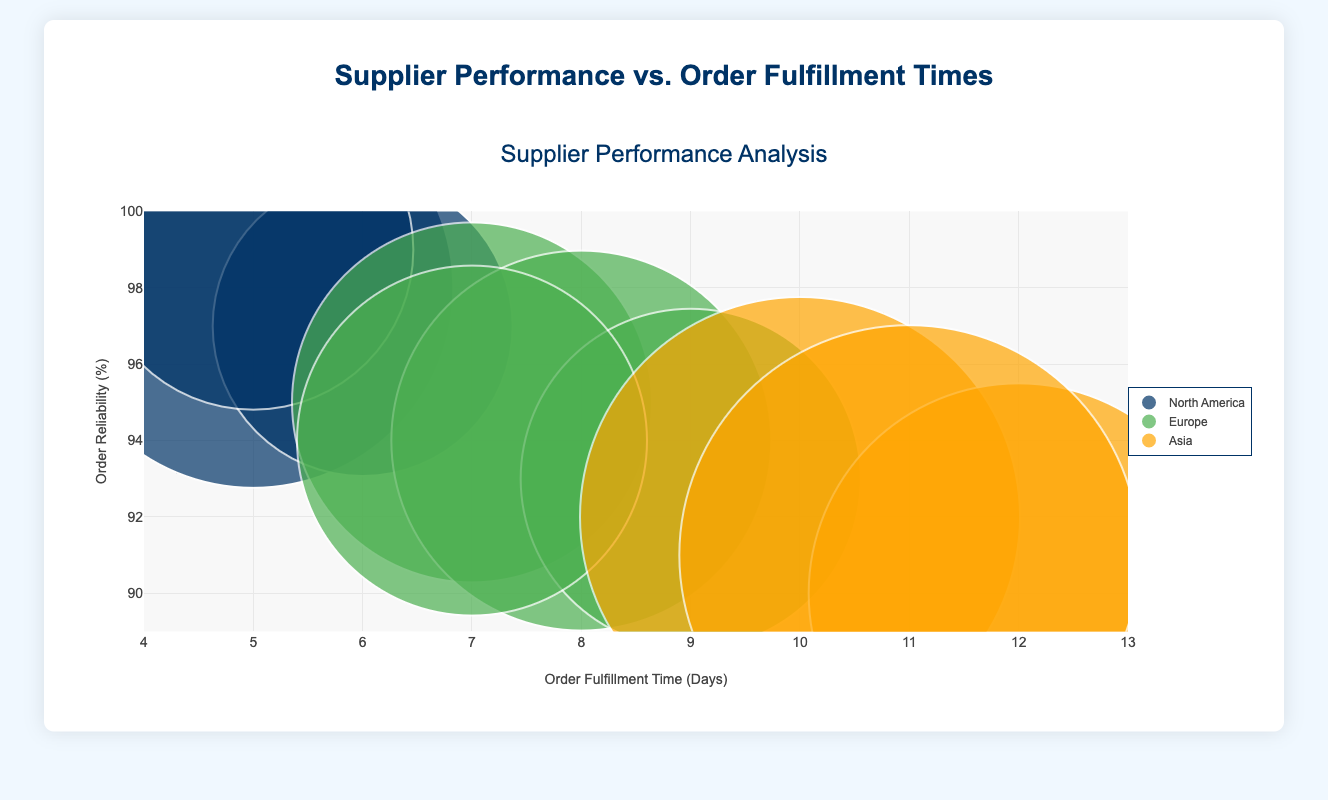What's the title of the chart? The title of the chart, written at the top in a font size of 24, is "Supplier Performance Analysis". The title often helps the viewer understand the main focus of the chart.
Answer: Supplier Performance Analysis Which supplier has the highest order reliability percentage? By looking at the y-axis (Order Reliability %), Ryder Supply Chain Solutions in North America has the highest value at 99%.
Answer: Ryder Supply Chain Solutions What is the average order size for suppliers in Europe? Calculate the average of the order sizes of European suppliers: (180 + 190 + 170 + 175) / 4. Sum = 715, Average = 715/4
Answer: 178.75 Which location has suppliers with the shortest and longest order fulfillment times? North American suppliers have the shortest and longest times: DHL Supply Chain and Ryder Supply Chain Solutions both with 5 days, while Expeditors in Asia has the longest with 12 days.
Answer: North America (shortest) and Asia (longest) How many suppliers are from North America? There are three suppliers from North America as indicated by the dots in the same color representing North America.
Answer: 3 Compare the order reliability of suppliers from Asia with those from Europe. The suppliers from Asia have reliability percentages of 92, 90, and 91. The suppliers from Europe have reliabilities of 95, 94, 93, and 94. The mean for Asia is (92 + 90 + 91) / 3 = 91%, and for Europe it is (95 + 94 + 93 + 94) / 4 = 94%.
Answer: Europe generally has higher order reliability What is the total sum of the average order sizes for suppliers from Asia? Sum the average order sizes of Asian suppliers: 220 + 210 + 230 = 660.
Answer: 660 Does any supplier have both high reliability and low order fulfillment time? By checking the chart, Ryder Supply Chain Solutions from North America has both high reliability (99%) and low order fulfillment time (5 days).
Answer: Yes, Ryder Supply Chain Solutions Which supplier from Europe has the largest bubble size, and what does it represent? UPS Supply Chain Solutions has the largest bubble size which represents the highest average order size among European suppliers: 190.
Answer: UPS Supply Chain Solutions (190) Is there any correlation between order fulfillment time and order reliability percentage visible in the chart? By visually inspecting the chart, a negative correlation is observed where suppliers with short order fulfillment times tend to have higher reliability percentages.
Answer: Negative correlation 